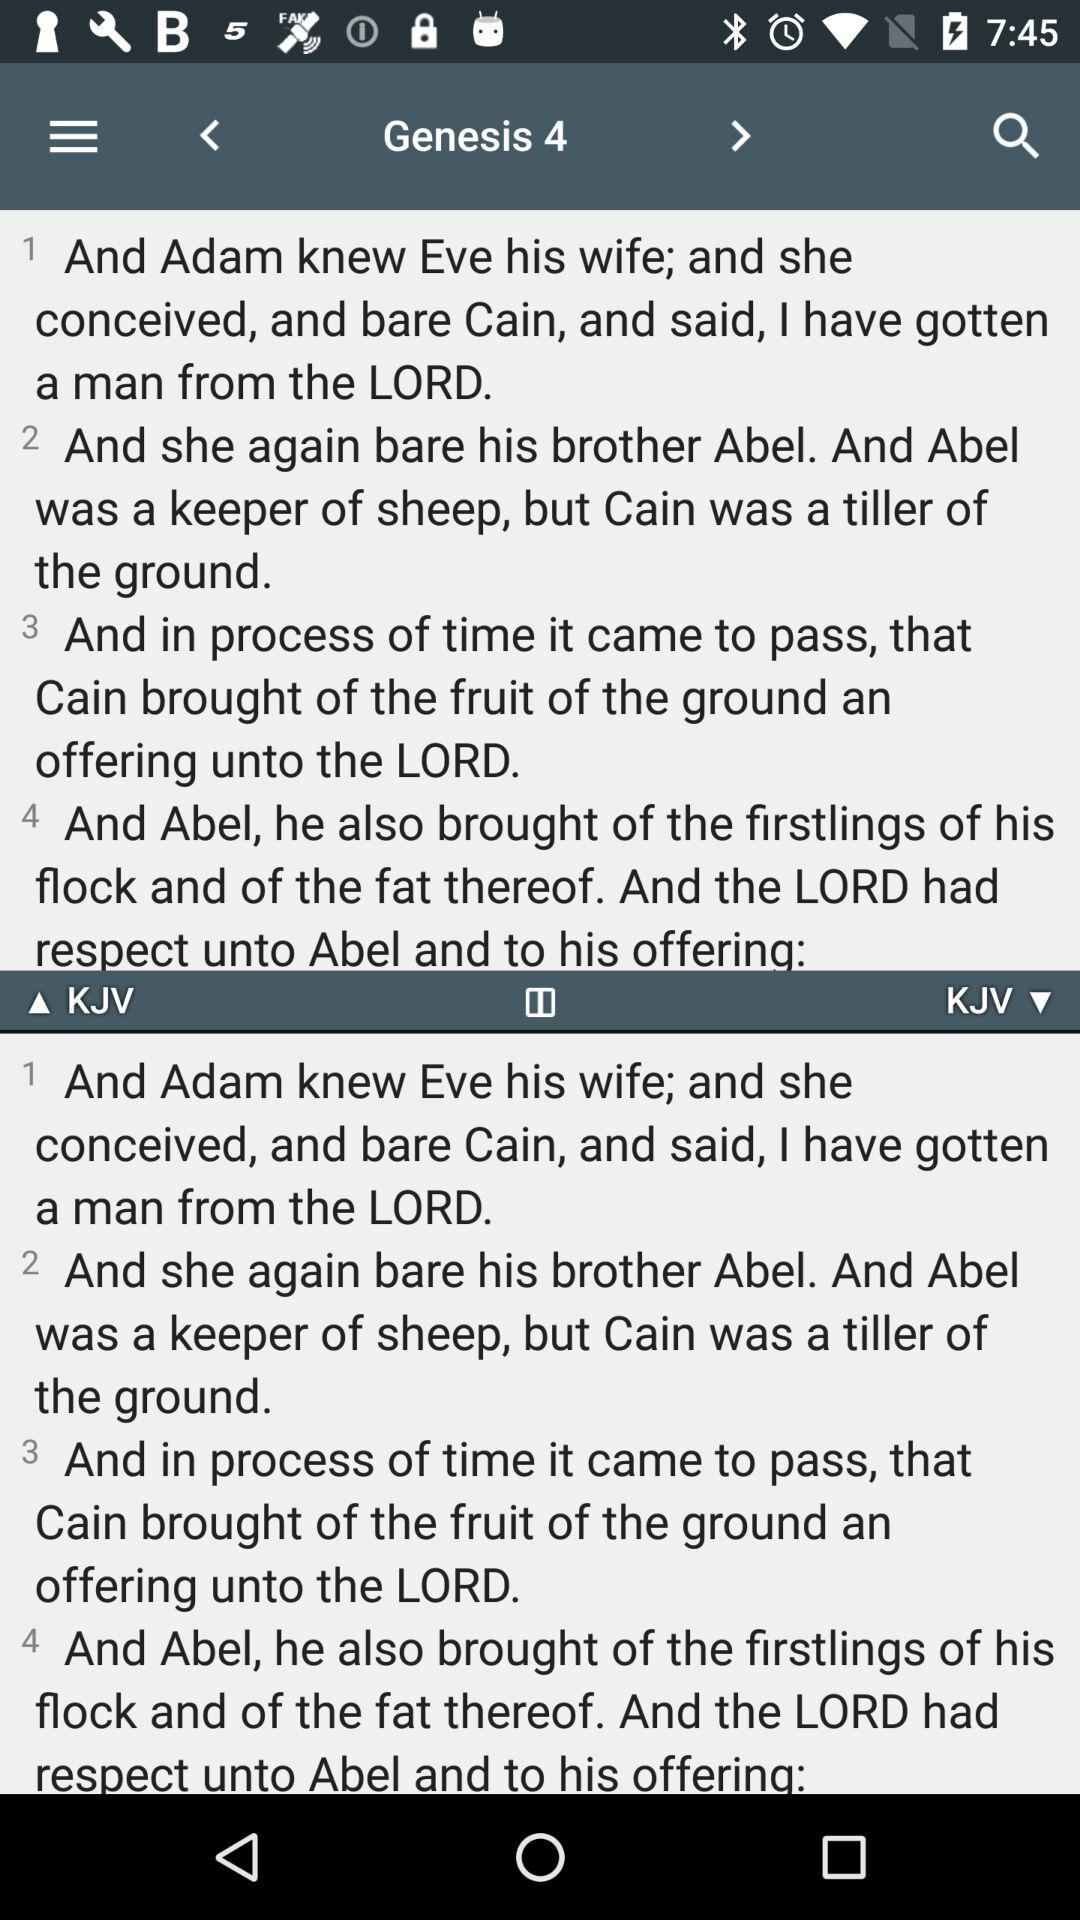What is the name of the first verse? 1 And Adam knew Eve his wife; and she conceived, and bare Cain, and said, I have gotten a man from the LORD. 